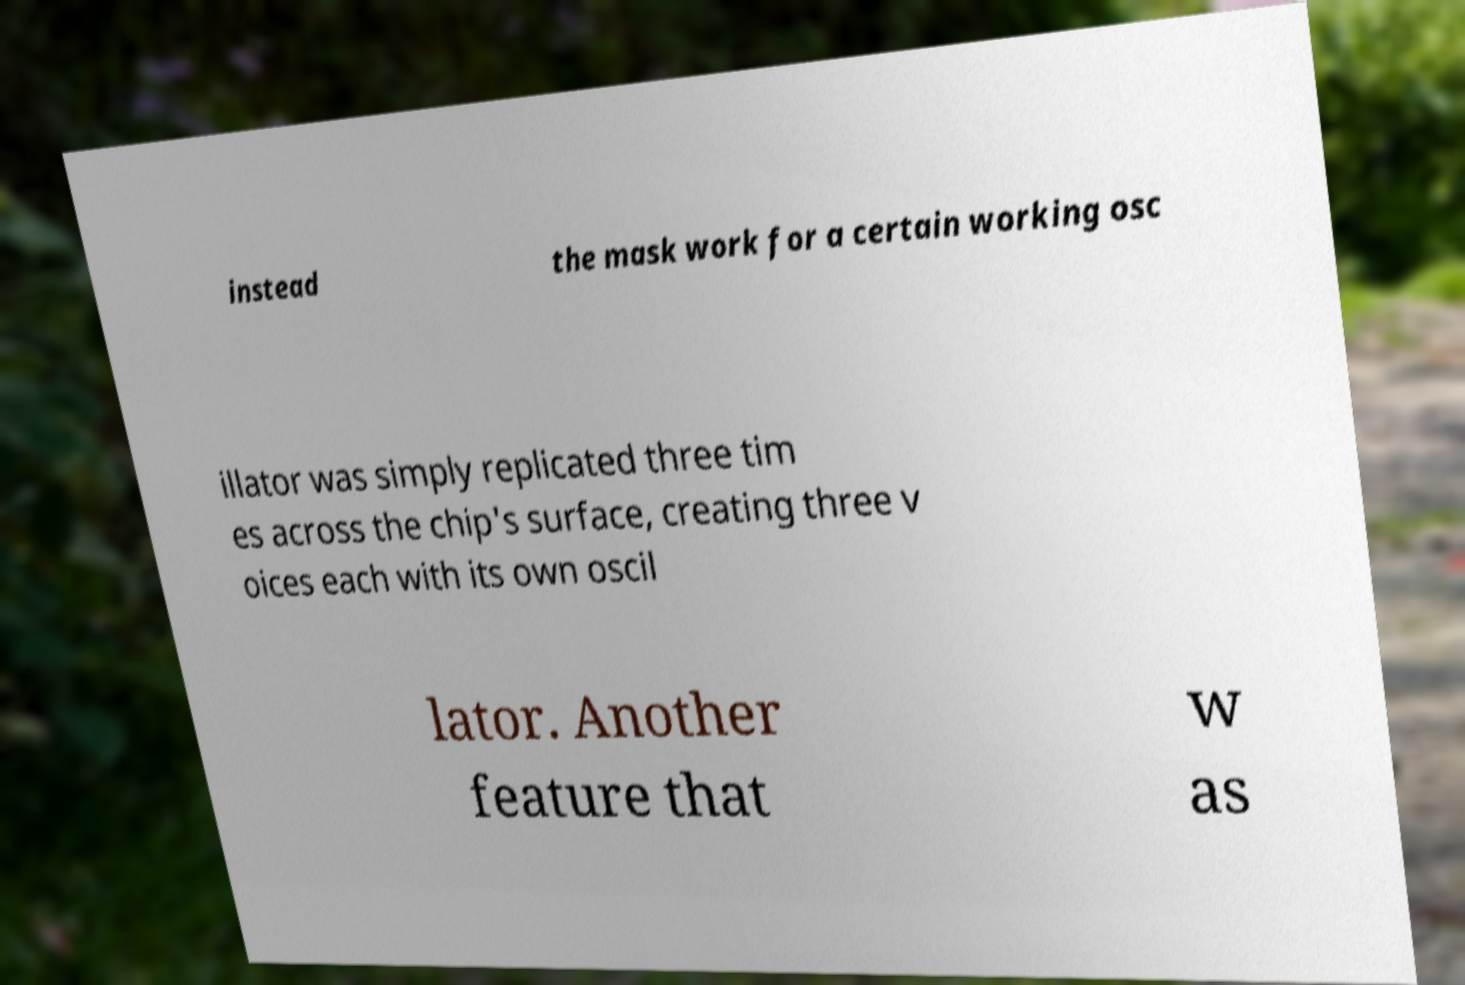There's text embedded in this image that I need extracted. Can you transcribe it verbatim? instead the mask work for a certain working osc illator was simply replicated three tim es across the chip's surface, creating three v oices each with its own oscil lator. Another feature that w as 